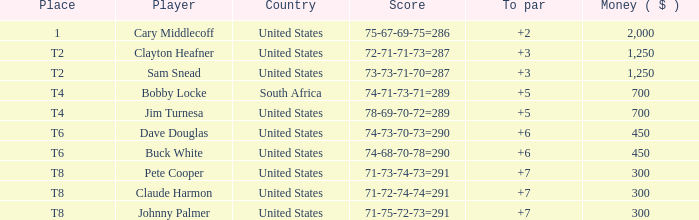What is meant by the johnny palmer having a to value above 6 in terms of money sum? 300.0. 